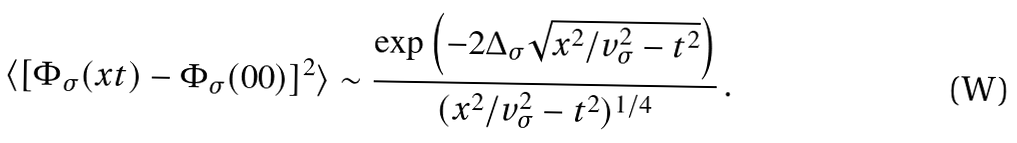Convert formula to latex. <formula><loc_0><loc_0><loc_500><loc_500>\langle [ \Phi _ { \sigma } ( x t ) - \Phi _ { \sigma } ( 0 0 ) ] ^ { 2 } \rangle \sim \frac { \exp \left ( - 2 \Delta _ { \sigma } \sqrt { x ^ { 2 } / v _ { \sigma } ^ { 2 } - t ^ { 2 } } \right ) } { ( x ^ { 2 } / v _ { \sigma } ^ { 2 } - t ^ { 2 } ) ^ { 1 / 4 } } \, .</formula> 